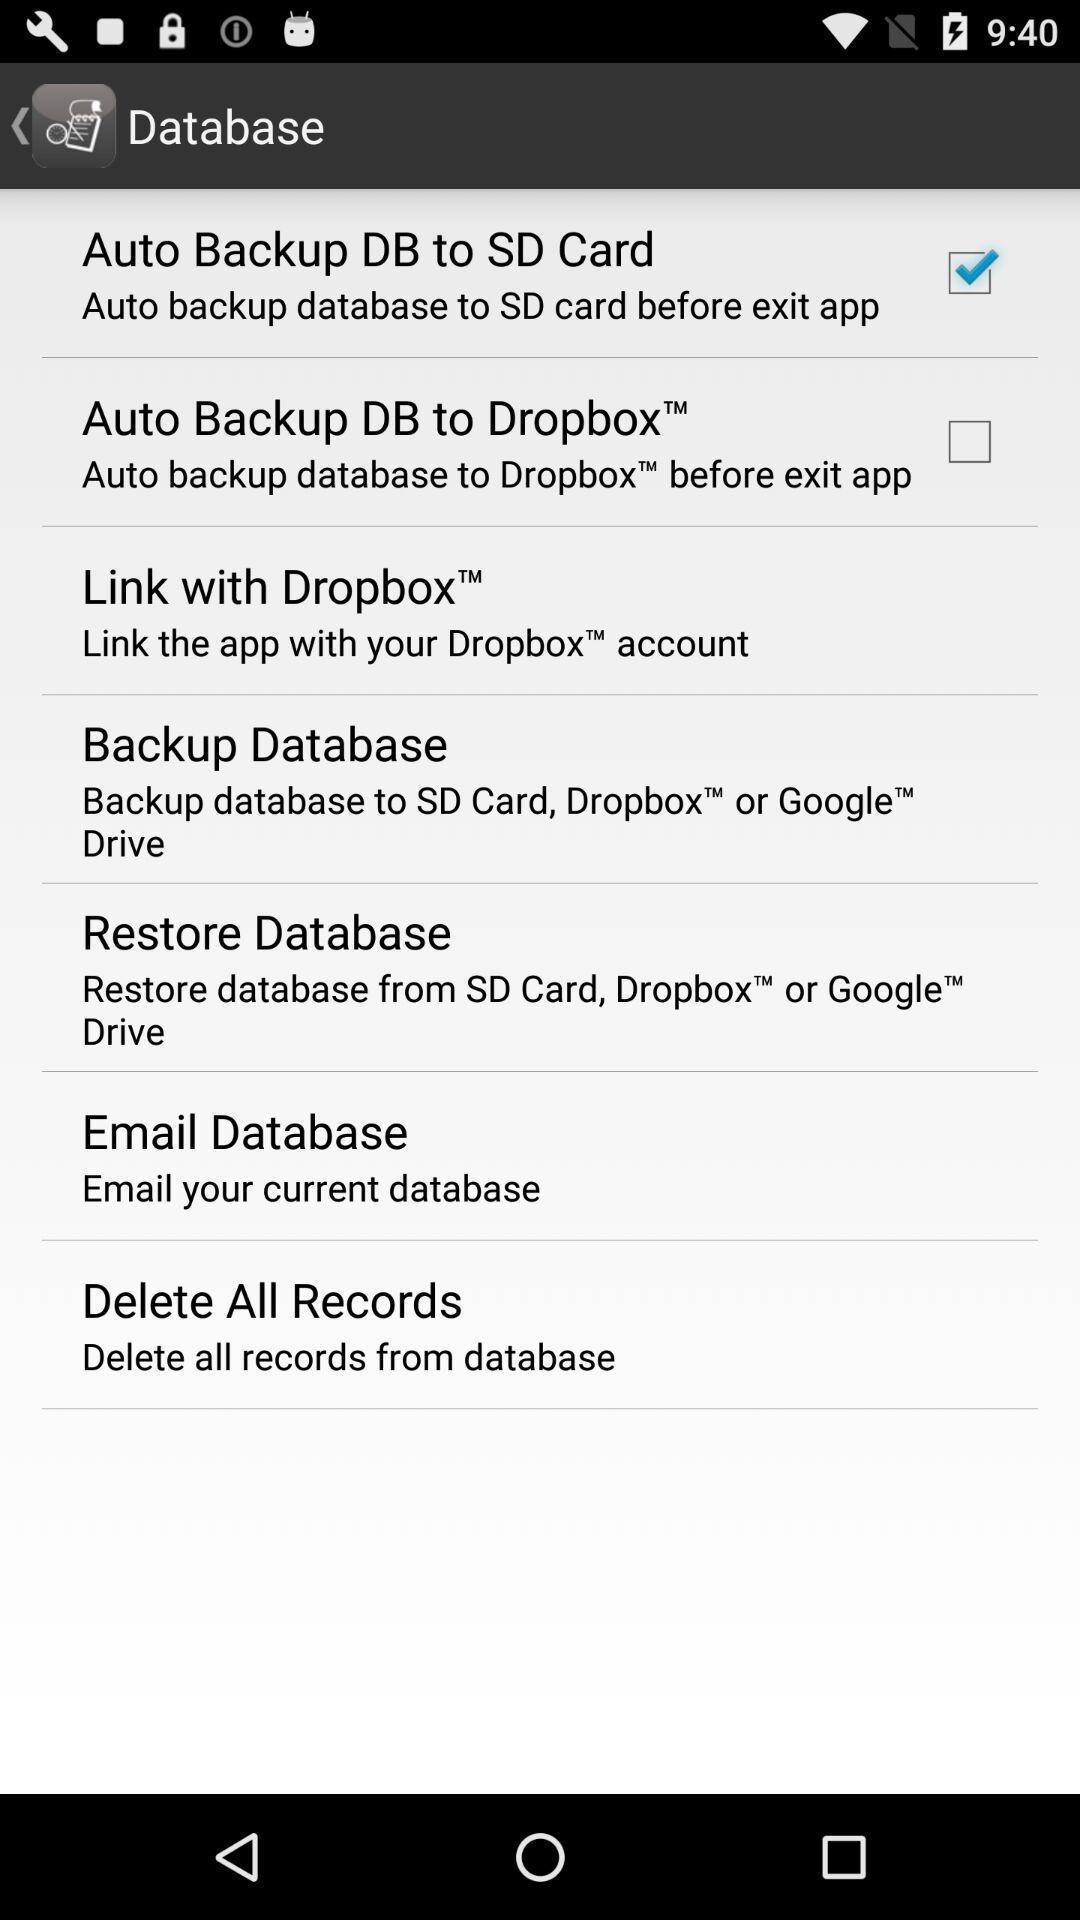Provide a textual representation of this image. Page displaying the list of options to select in database. 